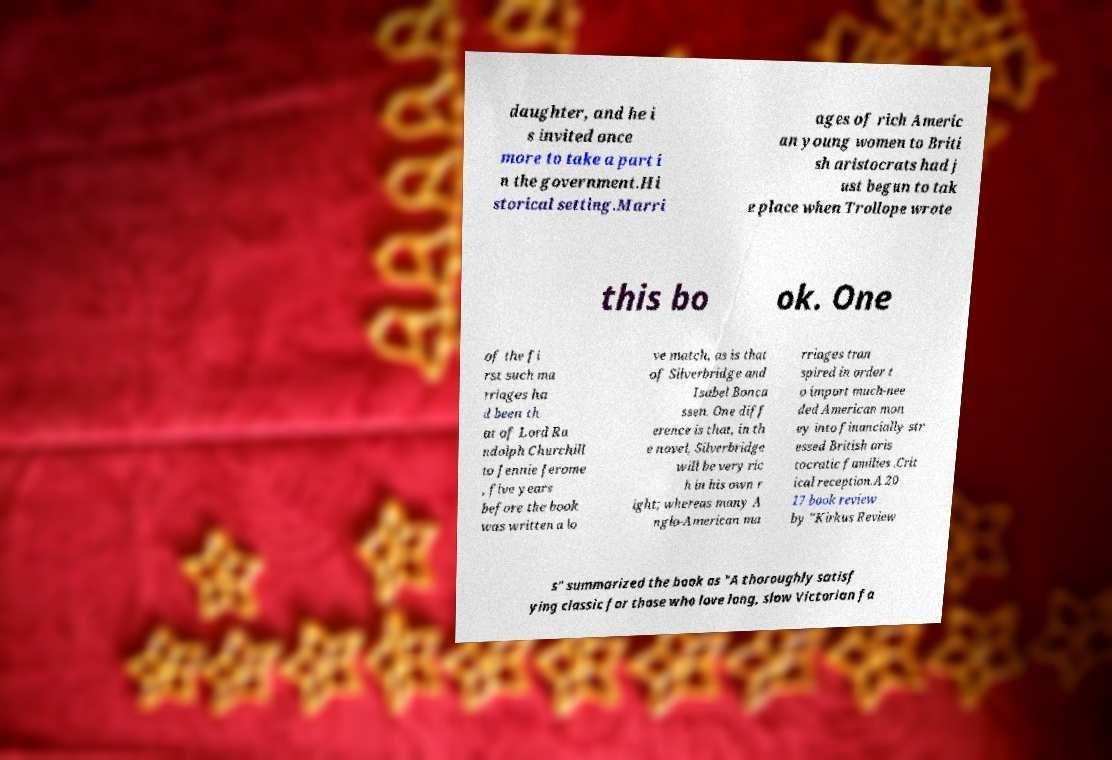I need the written content from this picture converted into text. Can you do that? daughter, and he i s invited once more to take a part i n the government.Hi storical setting.Marri ages of rich Americ an young women to Briti sh aristocrats had j ust begun to tak e place when Trollope wrote this bo ok. One of the fi rst such ma rriages ha d been th at of Lord Ra ndolph Churchill to Jennie Jerome , five years before the book was written a lo ve match, as is that of Silverbridge and Isabel Bonca ssen. One diff erence is that, in th e novel, Silverbridge will be very ric h in his own r ight; whereas many A nglo-American ma rriages tran spired in order t o import much-nee ded American mon ey into financially str essed British aris tocratic families .Crit ical reception.A 20 17 book review by "Kirkus Review s" summarized the book as "A thoroughly satisf ying classic for those who love long, slow Victorian fa 